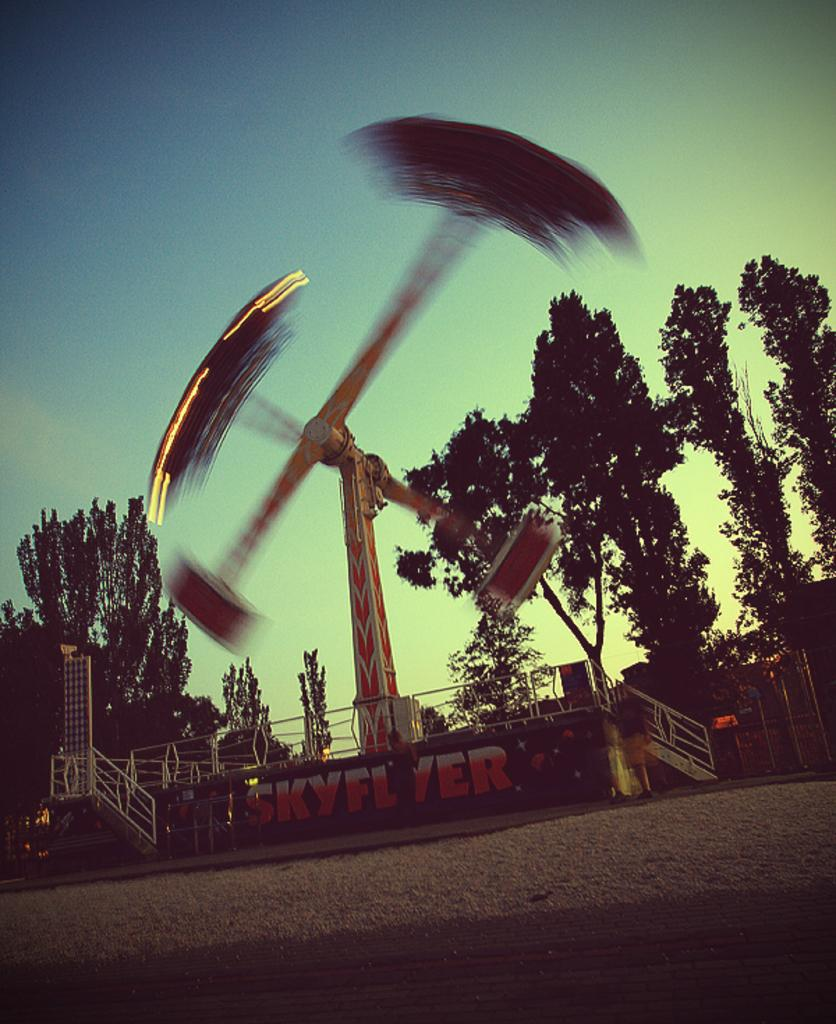What is located in the foreground of the image? There is a board and a pendulum wheel game in the foreground of the image. What type of vegetation is visible in the foreground of the image? There are trees in the foreground of the image. What can be seen in the background of the image? The sky is visible in the background of the image. When was the image taken? The image was taken during the day. How many visitors can be seen playing the pendulum wheel game in the image? There is no indication of visitors in the image; it only shows a board, a pendulum wheel game, trees, and the sky. What impulse caused the pendulum wheel game to be included in the image? The image was not created with a specific impulse in mind; it simply captures the scene as it was at the time of the photograph. 